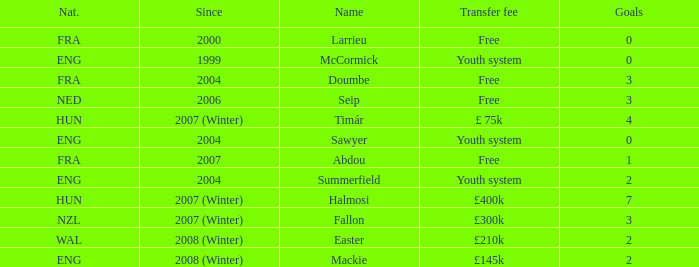For the player with a transfer fee of £400k, what nationality do they hold? HUN. 